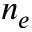<formula> <loc_0><loc_0><loc_500><loc_500>n _ { e }</formula> 